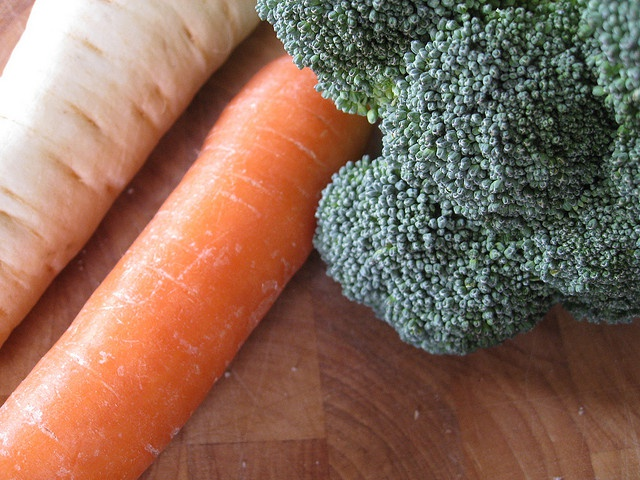Describe the objects in this image and their specific colors. I can see broccoli in lightpink, black, teal, darkgray, and darkgreen tones, carrot in lightpink, salmon, brown, and red tones, and carrot in lightpink, lightgray, tan, and salmon tones in this image. 